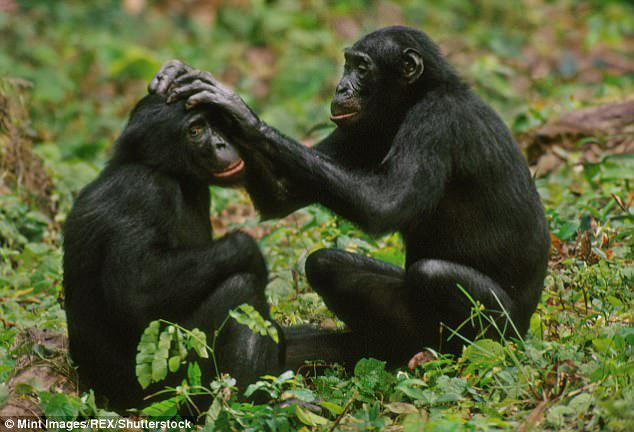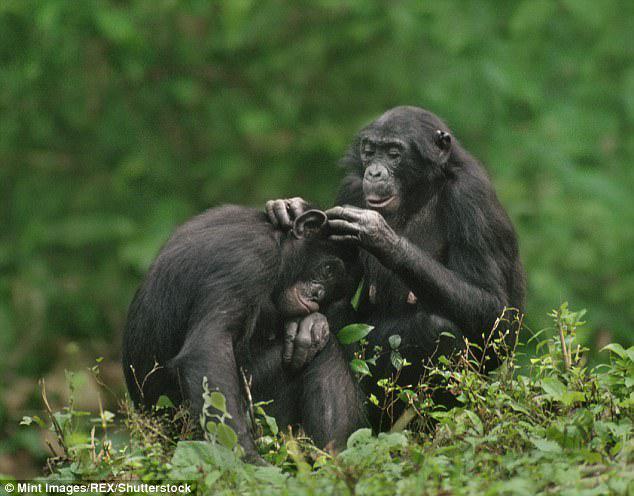The first image is the image on the left, the second image is the image on the right. For the images shown, is this caption "Each image shows exactly two chimps sitting close together, and at least one image shows a chimp grooming the fur of the other." true? Answer yes or no. Yes. The first image is the image on the left, the second image is the image on the right. Evaluate the accuracy of this statement regarding the images: "The right image contains exactly two chimpanzees.". Is it true? Answer yes or no. Yes. 